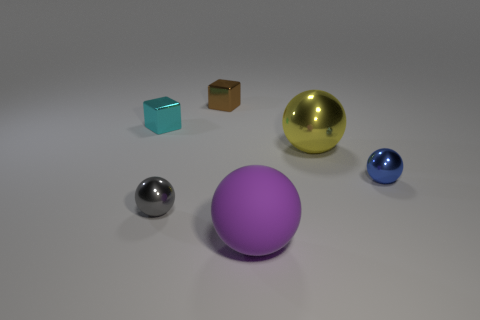Do the yellow sphere and the metal ball to the right of the large yellow metallic object have the same size?
Your response must be concise. No. How many cubes are either large brown metal objects or big purple rubber things?
Offer a very short reply. 0. Are there any tiny red metallic cylinders?
Provide a succinct answer. No. There is a brown metal thing that is the same shape as the cyan object; what size is it?
Your answer should be compact. Small. What is the shape of the object that is behind the tiny cube in front of the tiny brown block?
Ensure brevity in your answer.  Cube. How many yellow objects are matte objects or large metallic balls?
Offer a terse response. 1. The matte sphere is what color?
Give a very brief answer. Purple. Is the size of the purple thing the same as the gray object?
Your answer should be compact. No. Is there anything else that is the same shape as the purple object?
Provide a succinct answer. Yes. Is the material of the tiny cyan cube the same as the sphere that is left of the purple object?
Give a very brief answer. Yes. 